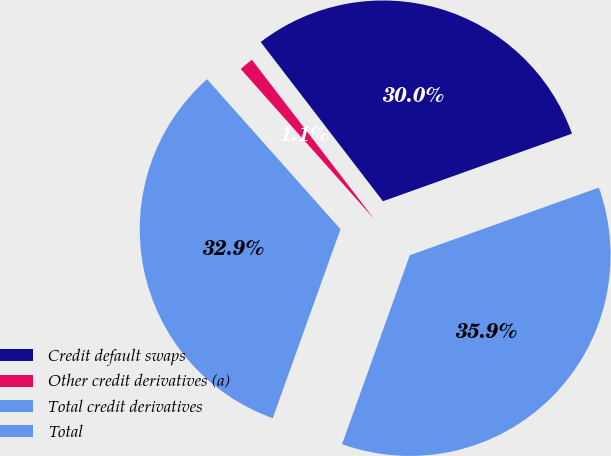Convert chart. <chart><loc_0><loc_0><loc_500><loc_500><pie_chart><fcel>Credit default swaps<fcel>Other credit derivatives (a)<fcel>Total credit derivatives<fcel>Total<nl><fcel>29.96%<fcel>1.15%<fcel>32.95%<fcel>35.95%<nl></chart> 